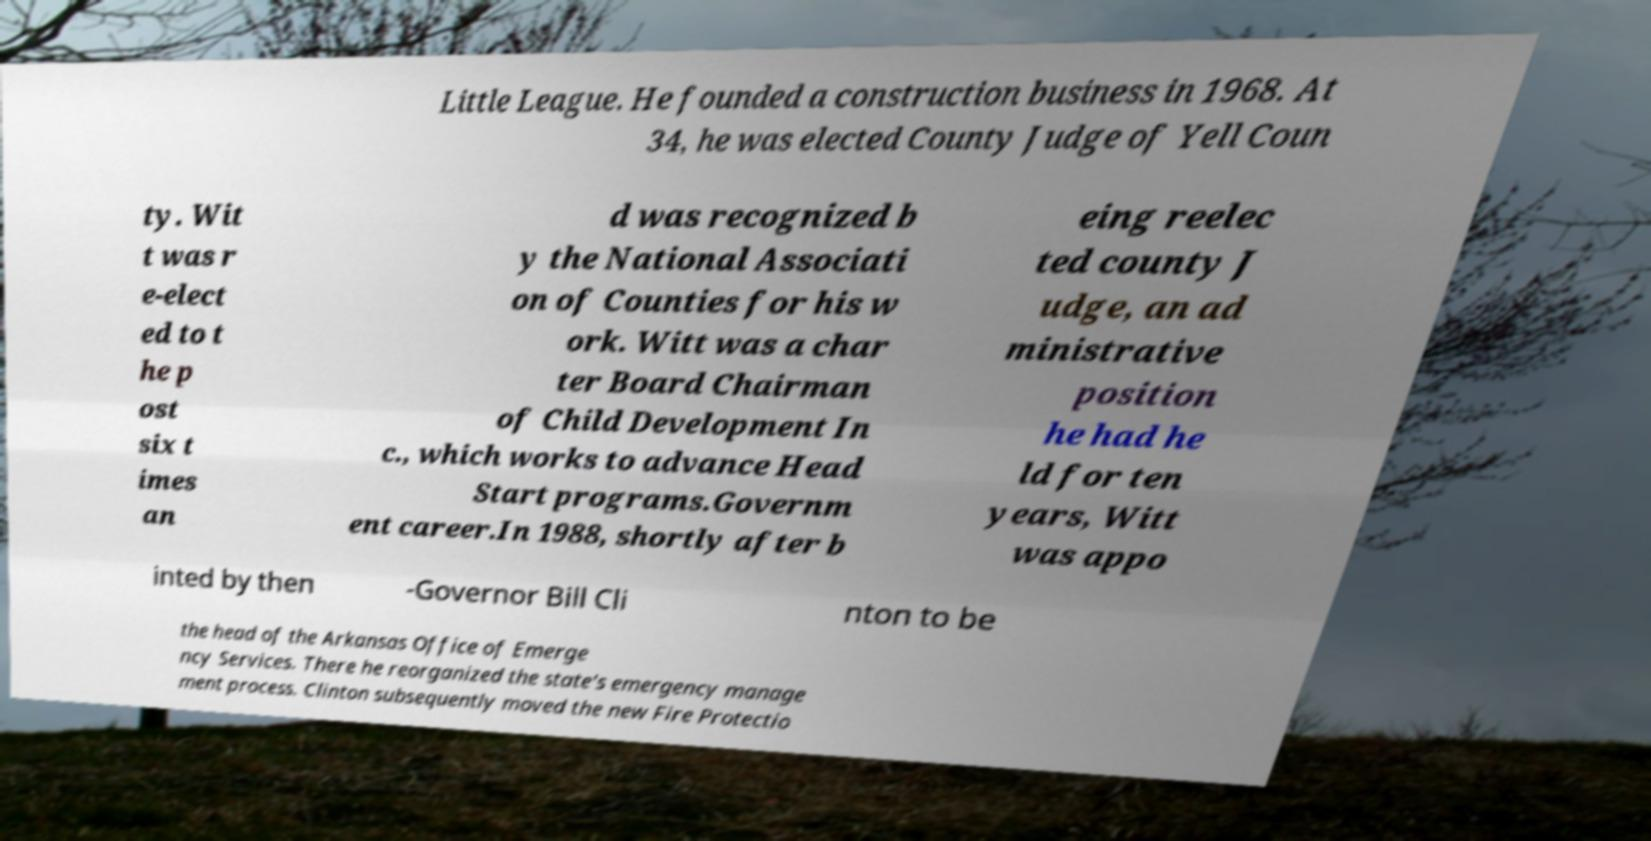Please read and relay the text visible in this image. What does it say? Little League. He founded a construction business in 1968. At 34, he was elected County Judge of Yell Coun ty. Wit t was r e-elect ed to t he p ost six t imes an d was recognized b y the National Associati on of Counties for his w ork. Witt was a char ter Board Chairman of Child Development In c., which works to advance Head Start programs.Governm ent career.In 1988, shortly after b eing reelec ted county J udge, an ad ministrative position he had he ld for ten years, Witt was appo inted by then -Governor Bill Cli nton to be the head of the Arkansas Office of Emerge ncy Services. There he reorganized the state's emergency manage ment process. Clinton subsequently moved the new Fire Protectio 